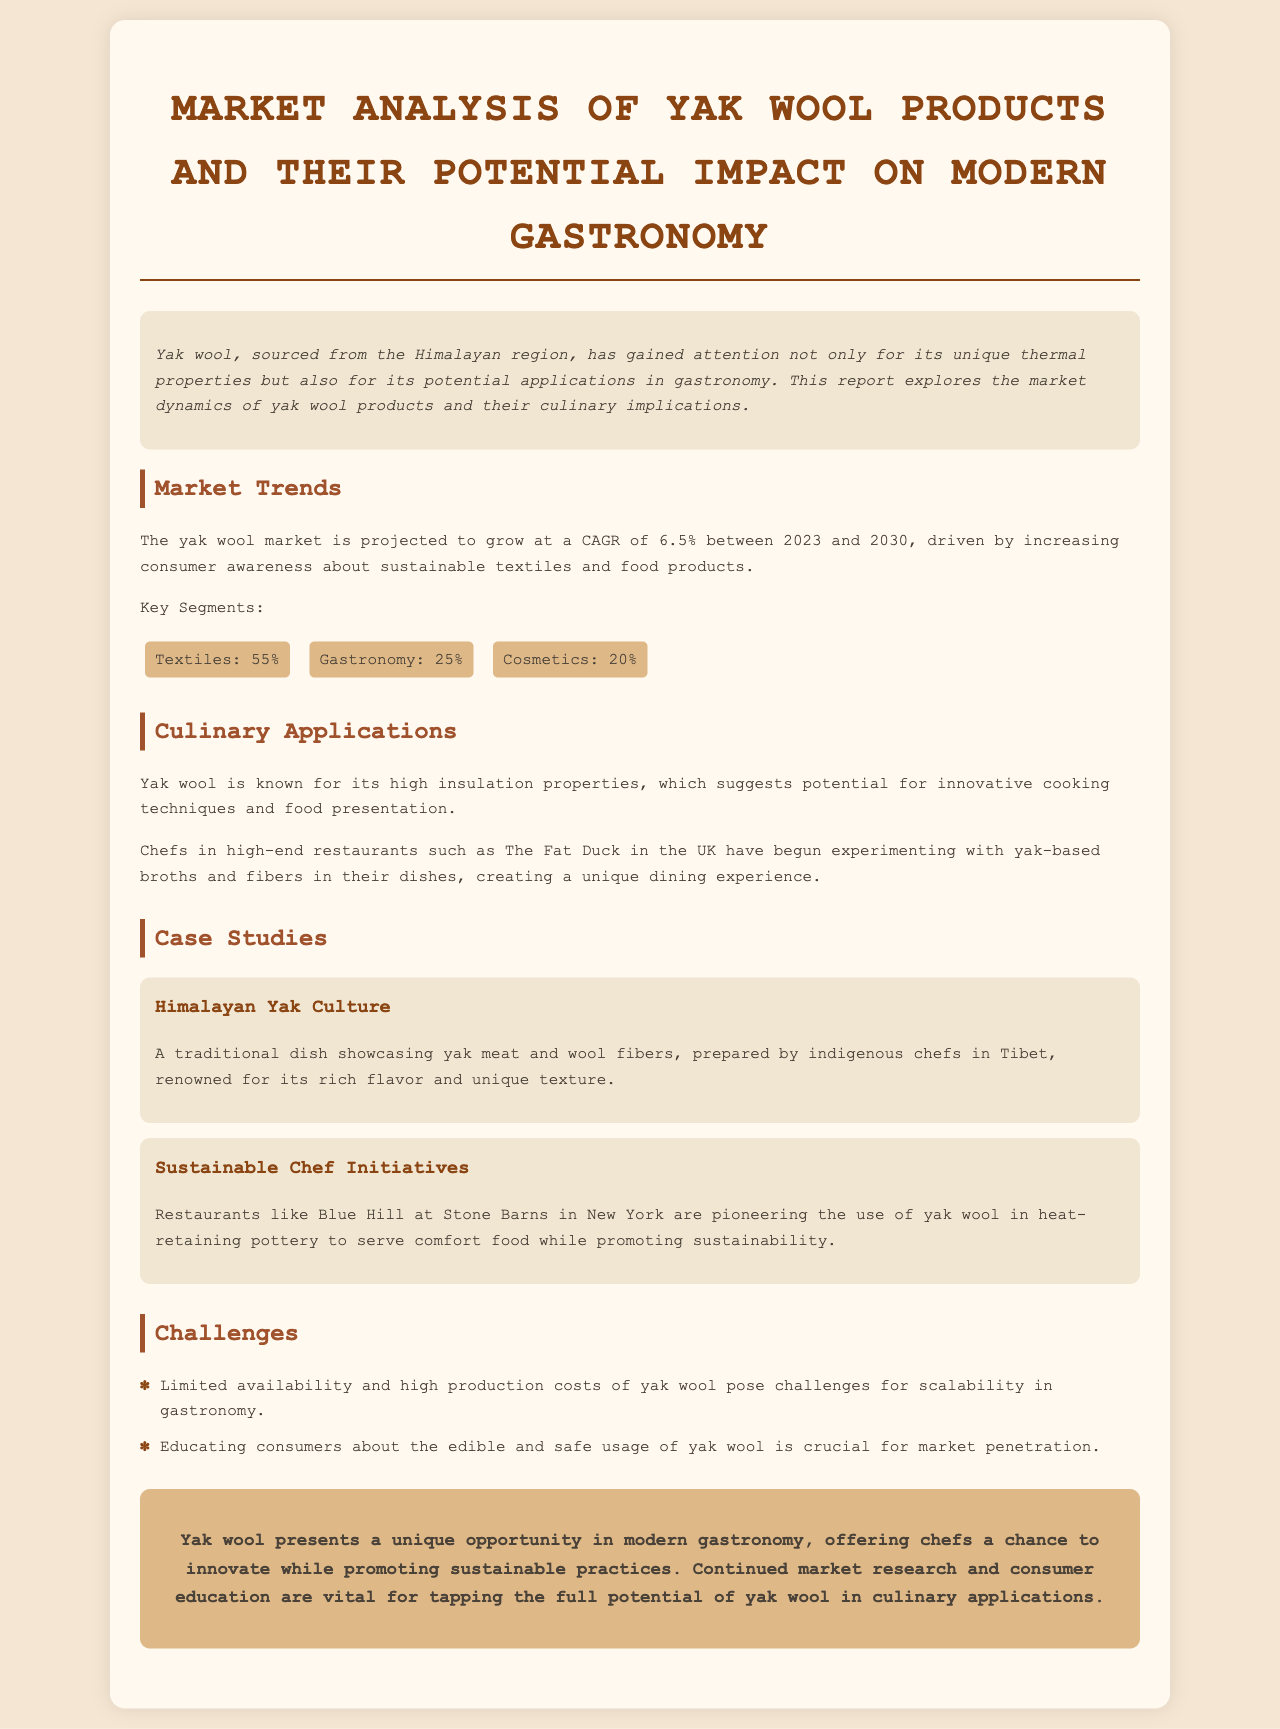What is the projected CAGR for the yak wool market? The report states that the yak wool market is projected to grow at a CAGR of 6.5% between 2023 and 2030.
Answer: 6.5% What segment accounts for the largest share in the yak wool market? The largest segment in the yak wool market is textiles, which accounts for 55%.
Answer: Textiles: 55% Which high-end restaurant is mentioned as experimenting with yak-based dishes? The document mentions The Fat Duck in the UK as a restaurant experimenting with yak-based broths and fibers.
Answer: The Fat Duck What is one challenge faced by the yak wool gastronomy market? One challenge is the limited availability and high production costs of yak wool.
Answer: Limited availability What unique cooking application is suggested for yak wool? Yak wool is known for its high insulation properties, suggesting its potential for innovative cooking techniques and food presentation.
Answer: Innovative cooking techniques What traditional dish is highlighted in the case studies section? The case studies mention a traditional dish showcasing yak meat and wool fibers prepared by indigenous chefs in Tibet.
Answer: Yak meat and wool fibers Who is pioneering the use of yak wool in heat-retaining pottery? Blue Hill at Stone Barns in New York is pioneering the use of yak wool in heat-retaining pottery.
Answer: Blue Hill at Stone Barns What is vital for tapping the full potential of yak wool in culinary applications? Continued market research and consumer education are vital for tapping the full potential of yak wool.
Answer: Market research and consumer education 